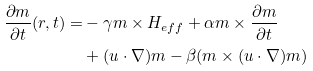Convert formula to latex. <formula><loc_0><loc_0><loc_500><loc_500>\frac { \partial m } { \partial t } ( r , t ) = & - \gamma m \times H _ { e f f } + \alpha m \times \frac { \partial m } { \partial t } \\ & + ( u \cdot \nabla ) m - \beta ( m \times ( u \cdot \nabla ) m )</formula> 